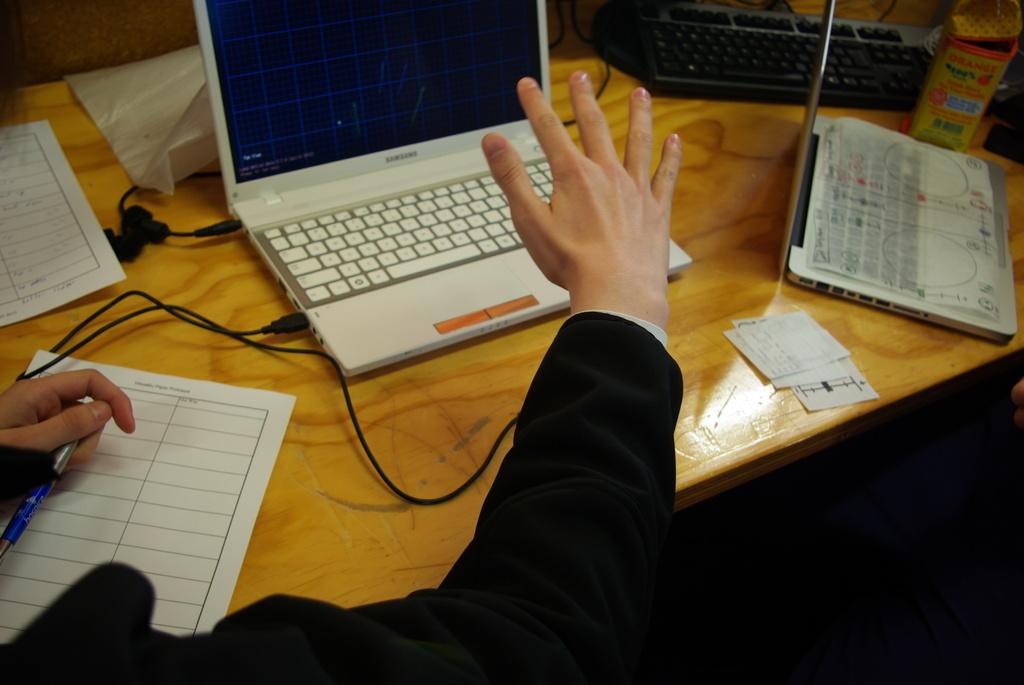What is the person in the image doing? The person is sitting in the image and holding a pen. What electronic devices are visible in the image? There are laptops in the image. What is the person likely using the pen for? The person might be using the pen to write or take notes on the papers in the image. What is the purpose of the keyboard in the image? The keyboard is likely used for typing on the laptops in the image. What can be found on the table in the image? There are objects on the table in the image, including laptops, a keyboard, and papers. What type of sand can be seen on the person's shoes in the image? There is no sand visible on the person's shoes in the image. How many wires are connected to the laptops in the image? The image does not show any wires connected to the laptops. 